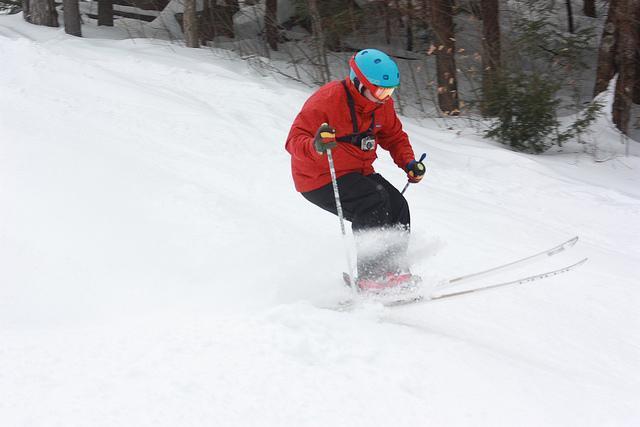How many people are there?
Give a very brief answer. 1. How many boats are to the right of the stop sign?
Give a very brief answer. 0. 